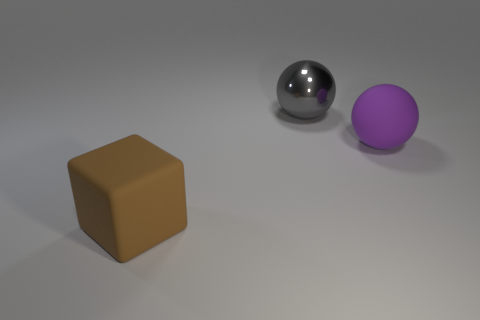How many other things are made of the same material as the gray thing?
Offer a terse response. 0. There is a rubber thing to the right of the large matte thing that is in front of the matte sphere; what number of large gray balls are on the left side of it?
Make the answer very short. 1. There is a large thing that is made of the same material as the brown block; what is its color?
Your answer should be compact. Purple. What number of things are purple spheres or big balls?
Your response must be concise. 2. What material is the thing behind the big rubber object behind the matte object in front of the matte ball?
Ensure brevity in your answer.  Metal. What material is the big sphere that is behind the purple rubber thing?
Offer a terse response. Metal. Is there a brown rubber object that has the same size as the rubber block?
Your answer should be very brief. No. What number of purple things are either large matte objects or blocks?
Keep it short and to the point. 1. What number of rubber blocks have the same color as the metallic object?
Your response must be concise. 0. Do the big gray thing and the purple ball have the same material?
Your answer should be compact. No. 